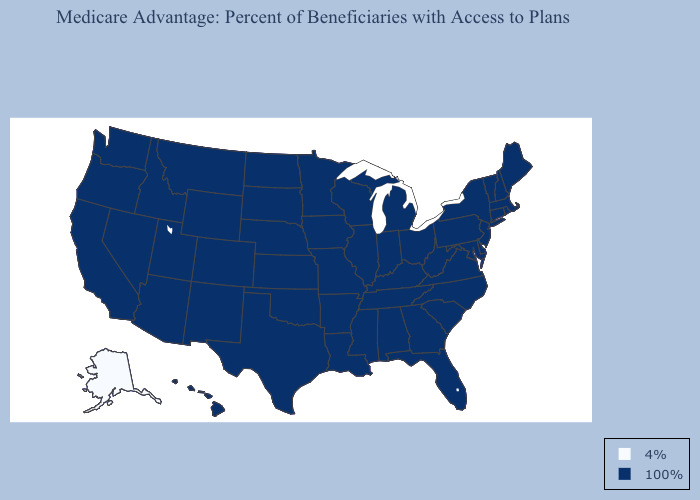Which states hav the highest value in the West?
Be succinct. Arizona, California, Colorado, Hawaii, Idaho, Montana, New Mexico, Nevada, Oregon, Utah, Washington, Wyoming. Does Texas have a lower value than Pennsylvania?
Give a very brief answer. No. What is the lowest value in the USA?
Quick response, please. 4%. What is the value of Texas?
Answer briefly. 100%. Name the states that have a value in the range 4%?
Be succinct. Alaska. What is the highest value in the USA?
Be succinct. 100%. What is the value of Alabama?
Be succinct. 100%. Name the states that have a value in the range 100%?
Be succinct. Alabama, Arkansas, Arizona, California, Colorado, Connecticut, Delaware, Florida, Georgia, Hawaii, Iowa, Idaho, Illinois, Indiana, Kansas, Kentucky, Louisiana, Massachusetts, Maryland, Maine, Michigan, Minnesota, Missouri, Mississippi, Montana, North Carolina, North Dakota, Nebraska, New Hampshire, New Jersey, New Mexico, Nevada, New York, Ohio, Oklahoma, Oregon, Pennsylvania, Rhode Island, South Carolina, South Dakota, Tennessee, Texas, Utah, Virginia, Vermont, Washington, Wisconsin, West Virginia, Wyoming. What is the lowest value in the MidWest?
Give a very brief answer. 100%. What is the lowest value in the USA?
Short answer required. 4%. What is the value of Missouri?
Be succinct. 100%. Does Alaska have the lowest value in the USA?
Give a very brief answer. Yes. 